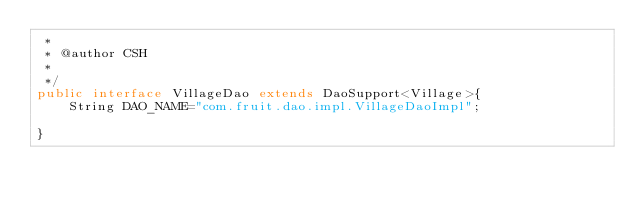Convert code to text. <code><loc_0><loc_0><loc_500><loc_500><_Java_> * 
 * @author CSH
 *
 */
public interface VillageDao extends DaoSupport<Village>{
    String DAO_NAME="com.fruit.dao.impl.VillageDaoImpl";

}
</code> 